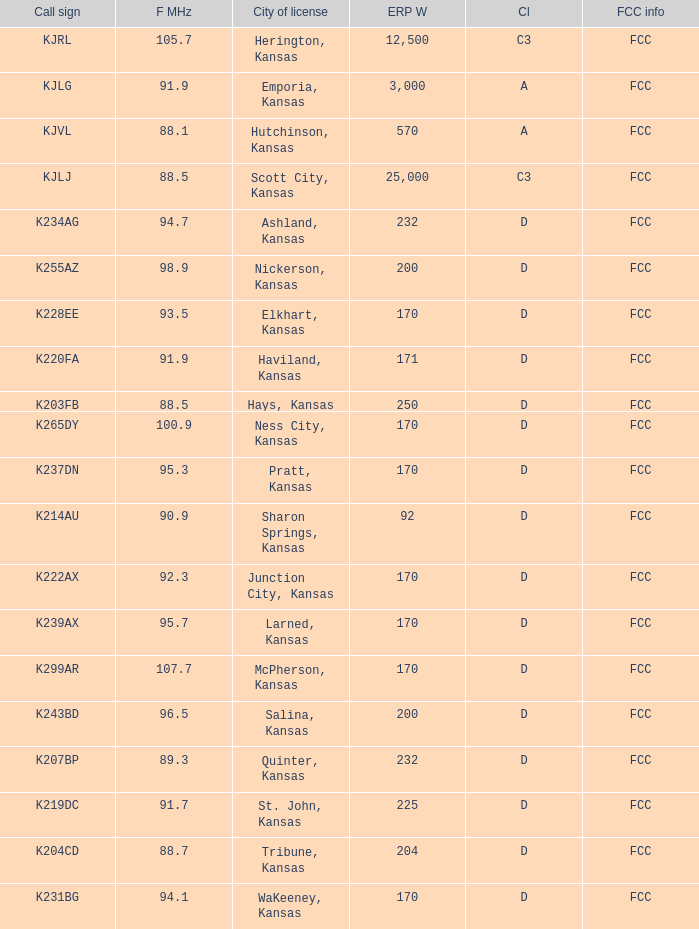Frequency MHz of 88.7 had what average erp w? 204.0. 